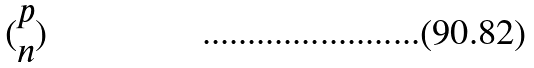Convert formula to latex. <formula><loc_0><loc_0><loc_500><loc_500>( \begin{matrix} p \\ n \end{matrix} )</formula> 